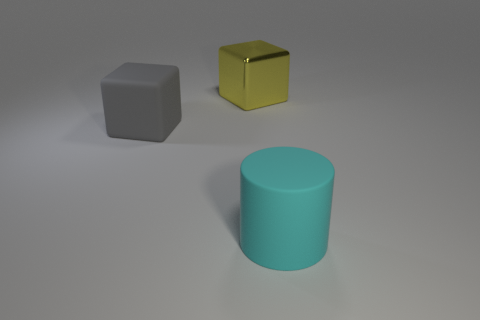Add 3 tiny red rubber objects. How many objects exist? 6 Subtract all blocks. How many objects are left? 1 Subtract all tiny cyan metallic spheres. Subtract all gray matte blocks. How many objects are left? 2 Add 3 cyan cylinders. How many cyan cylinders are left? 4 Add 3 small gray cylinders. How many small gray cylinders exist? 3 Subtract 0 gray balls. How many objects are left? 3 